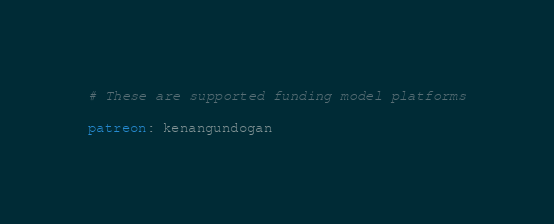Convert code to text. <code><loc_0><loc_0><loc_500><loc_500><_YAML_># These are supported funding model platforms

patreon: kenangundogan

</code> 